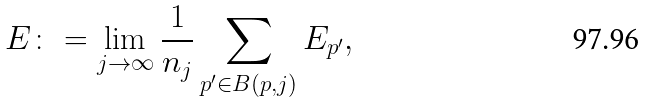<formula> <loc_0><loc_0><loc_500><loc_500>E \colon = \lim _ { j \to \infty } \frac { 1 } { n _ { j } } \sum _ { p ^ { \prime } \in B ( p , j ) } E _ { p ^ { \prime } } ,</formula> 